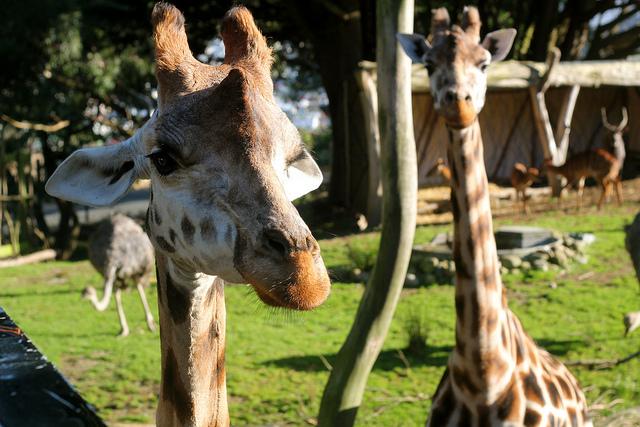Are the giraffes in a natural wild habitat?
Keep it brief. No. Is this in a zoo?
Answer briefly. Yes. How many birds on this picture?
Concise answer only. 1. Are the giraffes looking at the camera?
Quick response, please. Yes. 